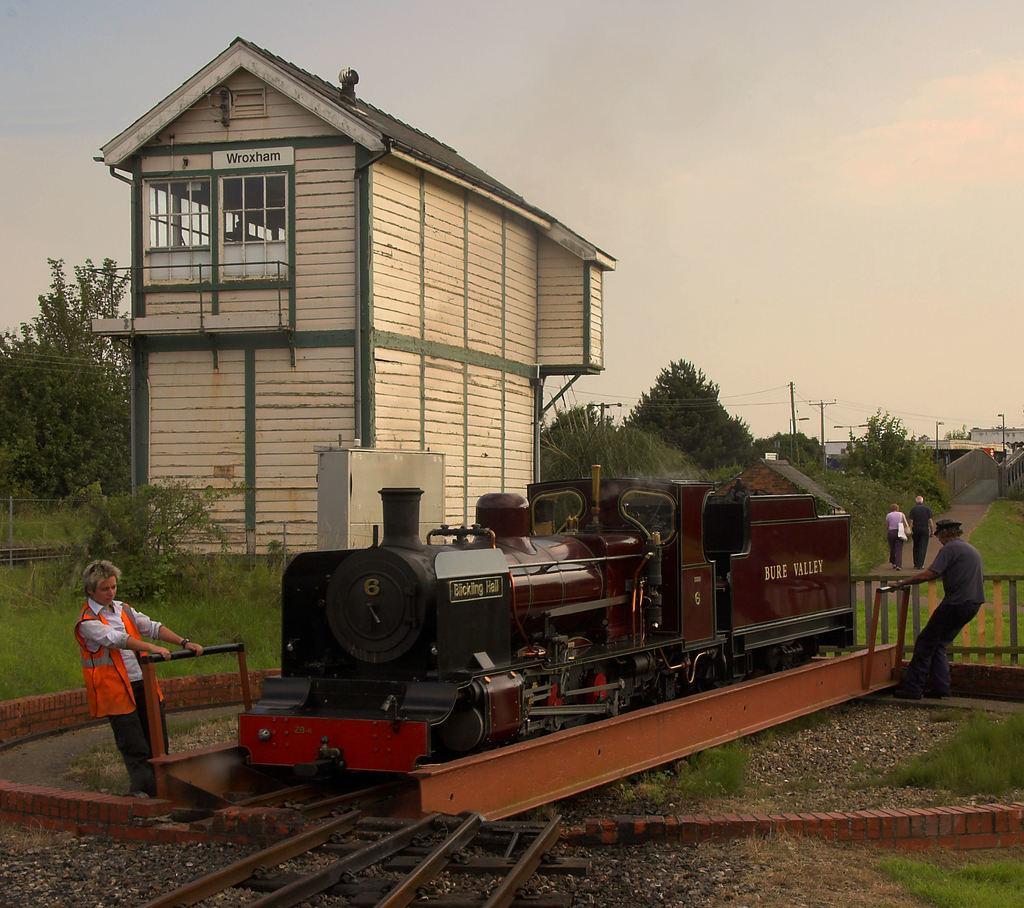Describe this image in one or two sentences. In the picture I can see a steam engine on the railway track. There is a man on the left side wearing a safety jacket. I can see another man on the right side. I can see two persons walking on the road. I can see a house on the left side. In the background, I can see the houses, electric poles and trees. There are clouds in the sky. 